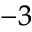<formula> <loc_0><loc_0><loc_500><loc_500>^ { - 3 }</formula> 